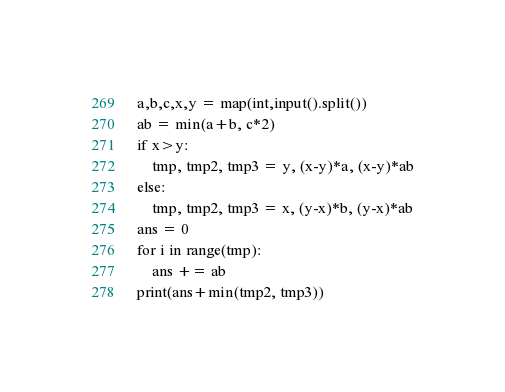Convert code to text. <code><loc_0><loc_0><loc_500><loc_500><_Python_>a,b,c,x,y = map(int,input().split())
ab = min(a+b, c*2)
if x>y:
    tmp, tmp2, tmp3 = y, (x-y)*a, (x-y)*ab
else:
    tmp, tmp2, tmp3 = x, (y-x)*b, (y-x)*ab
ans = 0
for i in range(tmp):
    ans += ab
print(ans+min(tmp2, tmp3))
</code> 